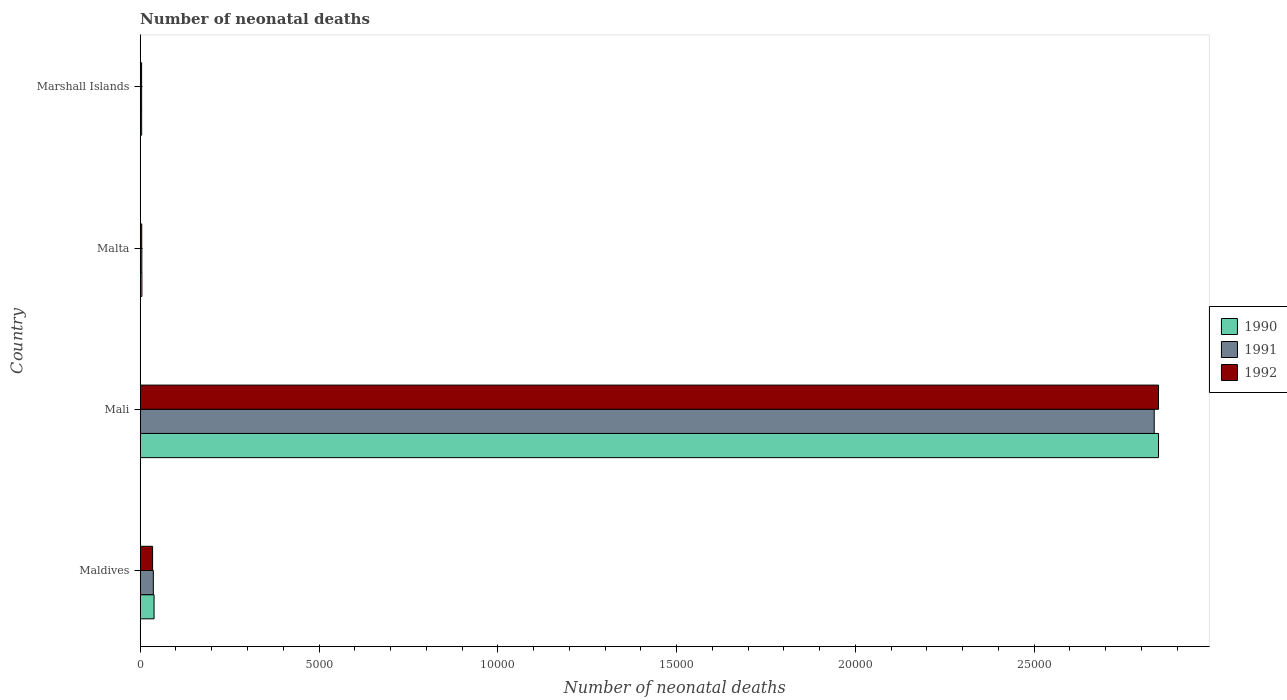How many groups of bars are there?
Offer a very short reply. 4. What is the label of the 4th group of bars from the top?
Offer a terse response. Maldives. In how many cases, is the number of bars for a given country not equal to the number of legend labels?
Make the answer very short. 0. What is the number of neonatal deaths in in 1992 in Marshall Islands?
Your response must be concise. 38. Across all countries, what is the maximum number of neonatal deaths in in 1991?
Keep it short and to the point. 2.84e+04. Across all countries, what is the minimum number of neonatal deaths in in 1990?
Ensure brevity in your answer.  40. In which country was the number of neonatal deaths in in 1990 maximum?
Give a very brief answer. Mali. In which country was the number of neonatal deaths in in 1990 minimum?
Ensure brevity in your answer.  Marshall Islands. What is the total number of neonatal deaths in in 1991 in the graph?
Offer a very short reply. 2.88e+04. What is the difference between the number of neonatal deaths in in 1992 in Maldives and that in Marshall Islands?
Your response must be concise. 308. What is the difference between the number of neonatal deaths in in 1991 in Marshall Islands and the number of neonatal deaths in in 1992 in Maldives?
Provide a short and direct response. -307. What is the average number of neonatal deaths in in 1992 per country?
Offer a terse response. 7226. What is the difference between the number of neonatal deaths in in 1991 and number of neonatal deaths in in 1990 in Malta?
Your answer should be compact. -2. In how many countries, is the number of neonatal deaths in in 1992 greater than 4000 ?
Make the answer very short. 1. What is the ratio of the number of neonatal deaths in in 1990 in Malta to that in Marshall Islands?
Make the answer very short. 1.18. Is the difference between the number of neonatal deaths in in 1991 in Mali and Marshall Islands greater than the difference between the number of neonatal deaths in in 1990 in Mali and Marshall Islands?
Offer a very short reply. No. What is the difference between the highest and the second highest number of neonatal deaths in in 1990?
Make the answer very short. 2.81e+04. What is the difference between the highest and the lowest number of neonatal deaths in in 1992?
Offer a terse response. 2.84e+04. What is the difference between two consecutive major ticks on the X-axis?
Your answer should be compact. 5000. Are the values on the major ticks of X-axis written in scientific E-notation?
Ensure brevity in your answer.  No. Does the graph contain any zero values?
Your response must be concise. No. How are the legend labels stacked?
Your answer should be compact. Vertical. What is the title of the graph?
Keep it short and to the point. Number of neonatal deaths. What is the label or title of the X-axis?
Provide a succinct answer. Number of neonatal deaths. What is the Number of neonatal deaths of 1990 in Maldives?
Give a very brief answer. 387. What is the Number of neonatal deaths in 1991 in Maldives?
Offer a terse response. 367. What is the Number of neonatal deaths of 1992 in Maldives?
Provide a succinct answer. 346. What is the Number of neonatal deaths in 1990 in Mali?
Provide a succinct answer. 2.85e+04. What is the Number of neonatal deaths of 1991 in Mali?
Give a very brief answer. 2.84e+04. What is the Number of neonatal deaths in 1992 in Mali?
Provide a succinct answer. 2.85e+04. What is the Number of neonatal deaths in 1991 in Malta?
Your response must be concise. 45. What is the Number of neonatal deaths of 1992 in Malta?
Your answer should be compact. 42. What is the Number of neonatal deaths in 1990 in Marshall Islands?
Offer a terse response. 40. What is the Number of neonatal deaths in 1991 in Marshall Islands?
Offer a very short reply. 39. Across all countries, what is the maximum Number of neonatal deaths in 1990?
Offer a very short reply. 2.85e+04. Across all countries, what is the maximum Number of neonatal deaths of 1991?
Provide a short and direct response. 2.84e+04. Across all countries, what is the maximum Number of neonatal deaths in 1992?
Your response must be concise. 2.85e+04. Across all countries, what is the minimum Number of neonatal deaths of 1990?
Your answer should be very brief. 40. Across all countries, what is the minimum Number of neonatal deaths of 1991?
Make the answer very short. 39. Across all countries, what is the minimum Number of neonatal deaths in 1992?
Offer a terse response. 38. What is the total Number of neonatal deaths of 1990 in the graph?
Provide a short and direct response. 2.90e+04. What is the total Number of neonatal deaths of 1991 in the graph?
Your answer should be compact. 2.88e+04. What is the total Number of neonatal deaths in 1992 in the graph?
Your answer should be compact. 2.89e+04. What is the difference between the Number of neonatal deaths in 1990 in Maldives and that in Mali?
Provide a short and direct response. -2.81e+04. What is the difference between the Number of neonatal deaths of 1991 in Maldives and that in Mali?
Offer a very short reply. -2.80e+04. What is the difference between the Number of neonatal deaths in 1992 in Maldives and that in Mali?
Keep it short and to the point. -2.81e+04. What is the difference between the Number of neonatal deaths of 1990 in Maldives and that in Malta?
Offer a terse response. 340. What is the difference between the Number of neonatal deaths of 1991 in Maldives and that in Malta?
Provide a succinct answer. 322. What is the difference between the Number of neonatal deaths in 1992 in Maldives and that in Malta?
Offer a very short reply. 304. What is the difference between the Number of neonatal deaths in 1990 in Maldives and that in Marshall Islands?
Give a very brief answer. 347. What is the difference between the Number of neonatal deaths in 1991 in Maldives and that in Marshall Islands?
Ensure brevity in your answer.  328. What is the difference between the Number of neonatal deaths in 1992 in Maldives and that in Marshall Islands?
Make the answer very short. 308. What is the difference between the Number of neonatal deaths in 1990 in Mali and that in Malta?
Your response must be concise. 2.84e+04. What is the difference between the Number of neonatal deaths of 1991 in Mali and that in Malta?
Give a very brief answer. 2.83e+04. What is the difference between the Number of neonatal deaths of 1992 in Mali and that in Malta?
Ensure brevity in your answer.  2.84e+04. What is the difference between the Number of neonatal deaths in 1990 in Mali and that in Marshall Islands?
Offer a very short reply. 2.84e+04. What is the difference between the Number of neonatal deaths in 1991 in Mali and that in Marshall Islands?
Ensure brevity in your answer.  2.83e+04. What is the difference between the Number of neonatal deaths in 1992 in Mali and that in Marshall Islands?
Keep it short and to the point. 2.84e+04. What is the difference between the Number of neonatal deaths of 1991 in Malta and that in Marshall Islands?
Give a very brief answer. 6. What is the difference between the Number of neonatal deaths in 1992 in Malta and that in Marshall Islands?
Offer a very short reply. 4. What is the difference between the Number of neonatal deaths of 1990 in Maldives and the Number of neonatal deaths of 1991 in Mali?
Offer a very short reply. -2.80e+04. What is the difference between the Number of neonatal deaths of 1990 in Maldives and the Number of neonatal deaths of 1992 in Mali?
Make the answer very short. -2.81e+04. What is the difference between the Number of neonatal deaths in 1991 in Maldives and the Number of neonatal deaths in 1992 in Mali?
Your answer should be very brief. -2.81e+04. What is the difference between the Number of neonatal deaths in 1990 in Maldives and the Number of neonatal deaths in 1991 in Malta?
Provide a short and direct response. 342. What is the difference between the Number of neonatal deaths of 1990 in Maldives and the Number of neonatal deaths of 1992 in Malta?
Provide a succinct answer. 345. What is the difference between the Number of neonatal deaths of 1991 in Maldives and the Number of neonatal deaths of 1992 in Malta?
Offer a very short reply. 325. What is the difference between the Number of neonatal deaths in 1990 in Maldives and the Number of neonatal deaths in 1991 in Marshall Islands?
Provide a short and direct response. 348. What is the difference between the Number of neonatal deaths of 1990 in Maldives and the Number of neonatal deaths of 1992 in Marshall Islands?
Make the answer very short. 349. What is the difference between the Number of neonatal deaths in 1991 in Maldives and the Number of neonatal deaths in 1992 in Marshall Islands?
Ensure brevity in your answer.  329. What is the difference between the Number of neonatal deaths in 1990 in Mali and the Number of neonatal deaths in 1991 in Malta?
Give a very brief answer. 2.84e+04. What is the difference between the Number of neonatal deaths in 1990 in Mali and the Number of neonatal deaths in 1992 in Malta?
Offer a very short reply. 2.84e+04. What is the difference between the Number of neonatal deaths in 1991 in Mali and the Number of neonatal deaths in 1992 in Malta?
Provide a succinct answer. 2.83e+04. What is the difference between the Number of neonatal deaths in 1990 in Mali and the Number of neonatal deaths in 1991 in Marshall Islands?
Ensure brevity in your answer.  2.84e+04. What is the difference between the Number of neonatal deaths in 1990 in Mali and the Number of neonatal deaths in 1992 in Marshall Islands?
Your answer should be very brief. 2.84e+04. What is the difference between the Number of neonatal deaths in 1991 in Mali and the Number of neonatal deaths in 1992 in Marshall Islands?
Your response must be concise. 2.83e+04. What is the difference between the Number of neonatal deaths of 1990 in Malta and the Number of neonatal deaths of 1991 in Marshall Islands?
Your response must be concise. 8. What is the average Number of neonatal deaths of 1990 per country?
Offer a terse response. 7238. What is the average Number of neonatal deaths in 1991 per country?
Offer a very short reply. 7202.25. What is the average Number of neonatal deaths of 1992 per country?
Your answer should be very brief. 7226. What is the difference between the Number of neonatal deaths of 1990 and Number of neonatal deaths of 1991 in Maldives?
Make the answer very short. 20. What is the difference between the Number of neonatal deaths in 1991 and Number of neonatal deaths in 1992 in Maldives?
Offer a terse response. 21. What is the difference between the Number of neonatal deaths of 1990 and Number of neonatal deaths of 1991 in Mali?
Keep it short and to the point. 120. What is the difference between the Number of neonatal deaths of 1990 and Number of neonatal deaths of 1992 in Mali?
Give a very brief answer. 0. What is the difference between the Number of neonatal deaths of 1991 and Number of neonatal deaths of 1992 in Mali?
Provide a short and direct response. -120. What is the difference between the Number of neonatal deaths of 1990 and Number of neonatal deaths of 1991 in Malta?
Your answer should be compact. 2. What is the difference between the Number of neonatal deaths of 1990 and Number of neonatal deaths of 1992 in Malta?
Make the answer very short. 5. What is the difference between the Number of neonatal deaths of 1991 and Number of neonatal deaths of 1992 in Marshall Islands?
Keep it short and to the point. 1. What is the ratio of the Number of neonatal deaths of 1990 in Maldives to that in Mali?
Your answer should be compact. 0.01. What is the ratio of the Number of neonatal deaths in 1991 in Maldives to that in Mali?
Offer a terse response. 0.01. What is the ratio of the Number of neonatal deaths of 1992 in Maldives to that in Mali?
Make the answer very short. 0.01. What is the ratio of the Number of neonatal deaths in 1990 in Maldives to that in Malta?
Offer a terse response. 8.23. What is the ratio of the Number of neonatal deaths in 1991 in Maldives to that in Malta?
Offer a terse response. 8.16. What is the ratio of the Number of neonatal deaths of 1992 in Maldives to that in Malta?
Your response must be concise. 8.24. What is the ratio of the Number of neonatal deaths of 1990 in Maldives to that in Marshall Islands?
Make the answer very short. 9.68. What is the ratio of the Number of neonatal deaths in 1991 in Maldives to that in Marshall Islands?
Offer a very short reply. 9.41. What is the ratio of the Number of neonatal deaths in 1992 in Maldives to that in Marshall Islands?
Provide a succinct answer. 9.11. What is the ratio of the Number of neonatal deaths in 1990 in Mali to that in Malta?
Offer a terse response. 605.91. What is the ratio of the Number of neonatal deaths in 1991 in Mali to that in Malta?
Offer a terse response. 630.18. What is the ratio of the Number of neonatal deaths of 1992 in Mali to that in Malta?
Provide a short and direct response. 678.05. What is the ratio of the Number of neonatal deaths of 1990 in Mali to that in Marshall Islands?
Offer a terse response. 711.95. What is the ratio of the Number of neonatal deaths in 1991 in Mali to that in Marshall Islands?
Make the answer very short. 727.13. What is the ratio of the Number of neonatal deaths in 1992 in Mali to that in Marshall Islands?
Your answer should be very brief. 749.42. What is the ratio of the Number of neonatal deaths in 1990 in Malta to that in Marshall Islands?
Give a very brief answer. 1.18. What is the ratio of the Number of neonatal deaths in 1991 in Malta to that in Marshall Islands?
Offer a terse response. 1.15. What is the ratio of the Number of neonatal deaths in 1992 in Malta to that in Marshall Islands?
Provide a succinct answer. 1.11. What is the difference between the highest and the second highest Number of neonatal deaths in 1990?
Give a very brief answer. 2.81e+04. What is the difference between the highest and the second highest Number of neonatal deaths of 1991?
Offer a very short reply. 2.80e+04. What is the difference between the highest and the second highest Number of neonatal deaths in 1992?
Your response must be concise. 2.81e+04. What is the difference between the highest and the lowest Number of neonatal deaths of 1990?
Your response must be concise. 2.84e+04. What is the difference between the highest and the lowest Number of neonatal deaths of 1991?
Keep it short and to the point. 2.83e+04. What is the difference between the highest and the lowest Number of neonatal deaths of 1992?
Your answer should be very brief. 2.84e+04. 